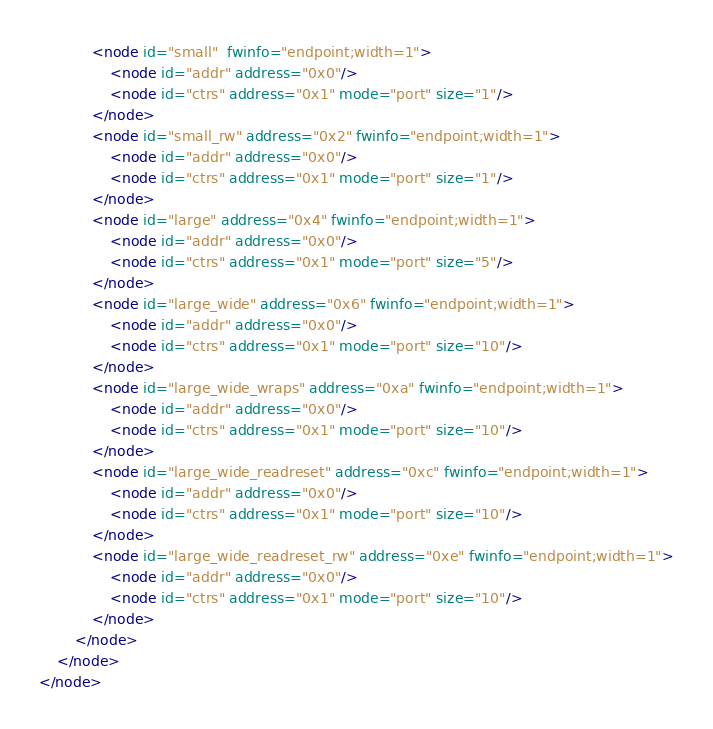Convert code to text. <code><loc_0><loc_0><loc_500><loc_500><_XML_>			<node id="small"  fwinfo="endpoint;width=1">
				<node id="addr" address="0x0"/>
				<node id="ctrs" address="0x1" mode="port" size="1"/>
			</node>
			<node id="small_rw" address="0x2" fwinfo="endpoint;width=1">
				<node id="addr" address="0x0"/>
				<node id="ctrs" address="0x1" mode="port" size="1"/>
			</node>
			<node id="large" address="0x4" fwinfo="endpoint;width=1">
				<node id="addr" address="0x0"/>
				<node id="ctrs" address="0x1" mode="port" size="5"/>
			</node>
			<node id="large_wide" address="0x6" fwinfo="endpoint;width=1">
				<node id="addr" address="0x0"/>
				<node id="ctrs" address="0x1" mode="port" size="10"/>
			</node>
			<node id="large_wide_wraps" address="0xa" fwinfo="endpoint;width=1">
				<node id="addr" address="0x0"/>
				<node id="ctrs" address="0x1" mode="port" size="10"/>
			</node>
			<node id="large_wide_readreset" address="0xc" fwinfo="endpoint;width=1">
				<node id="addr" address="0x0"/>
				<node id="ctrs" address="0x1" mode="port" size="10"/>
			</node>
			<node id="large_wide_readreset_rw" address="0xe" fwinfo="endpoint;width=1">
				<node id="addr" address="0x0"/>
				<node id="ctrs" address="0x1" mode="port" size="10"/>
			</node>
		</node>
	</node>
</node>
</code> 